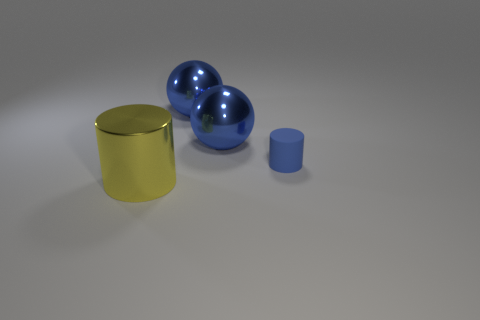Subtract all blue cylinders. How many cylinders are left? 1 Subtract 2 balls. How many balls are left? 0 Add 2 tiny things. How many objects exist? 6 Subtract all yellow cylinders. Subtract all green cubes. How many cylinders are left? 1 Subtract all purple cylinders. How many purple spheres are left? 0 Subtract all large red metallic balls. Subtract all tiny blue cylinders. How many objects are left? 3 Add 2 tiny blue rubber objects. How many tiny blue rubber objects are left? 3 Add 4 metallic cylinders. How many metallic cylinders exist? 5 Subtract 0 red spheres. How many objects are left? 4 